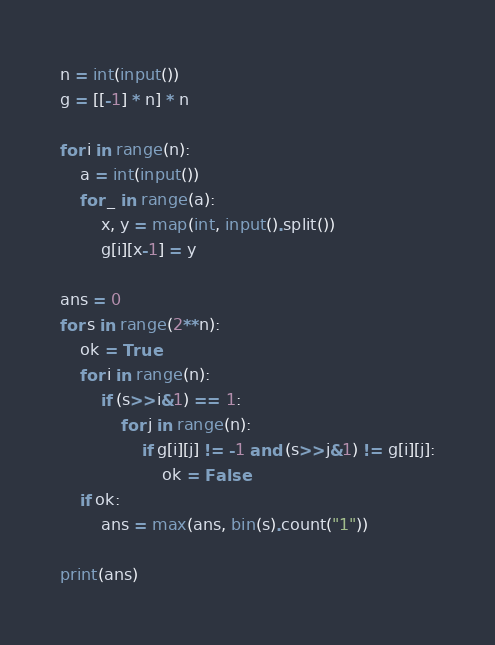<code> <loc_0><loc_0><loc_500><loc_500><_Python_>n = int(input())
g = [[-1] * n] * n

for i in range(n):
	a = int(input())
	for _ in range(a):
		x, y = map(int, input().split())
		g[i][x-1] = y

ans = 0
for s in range(2**n):
	ok = True
	for i in range(n):
		if (s>>i&1) == 1:
			for j in range(n):
				if g[i][j] != -1 and (s>>j&1) != g[i][j]:
                    ok = False
	if ok:
		ans = max(ans, bin(s).count("1"))

print(ans)
</code> 